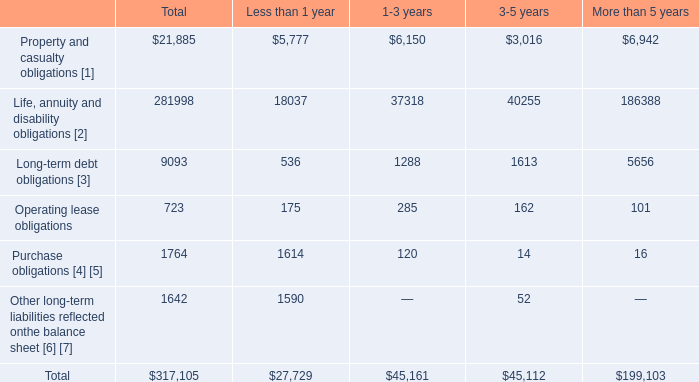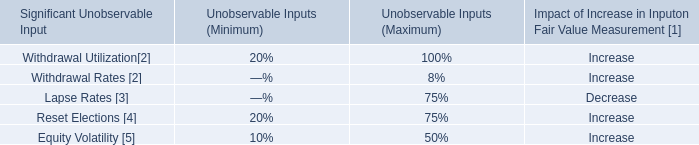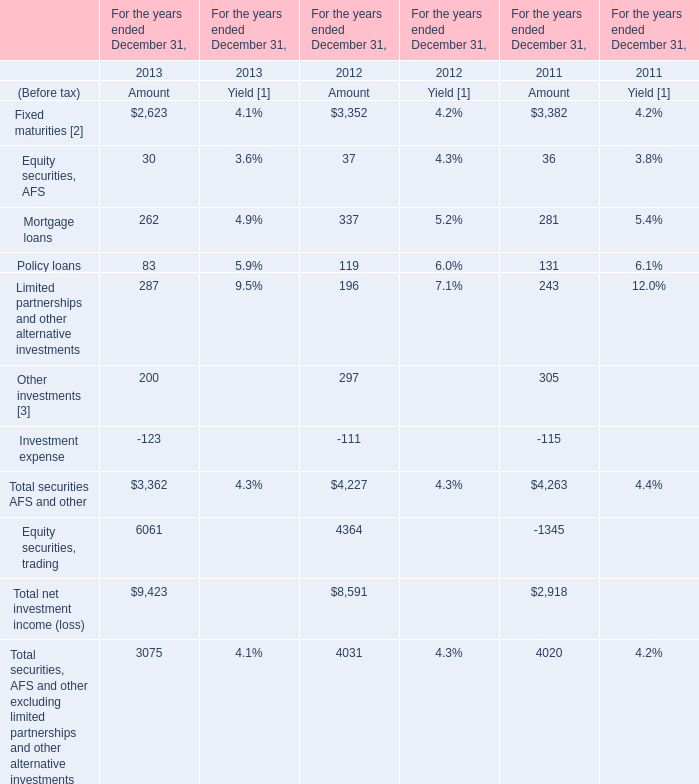In the year with the most Mortgage loans, what is the growth rate of Policy loans? 
Computations: ((119 - 131) / 131)
Answer: -0.0916. 